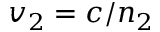<formula> <loc_0><loc_0><loc_500><loc_500>v _ { 2 } = c / n _ { 2 }</formula> 